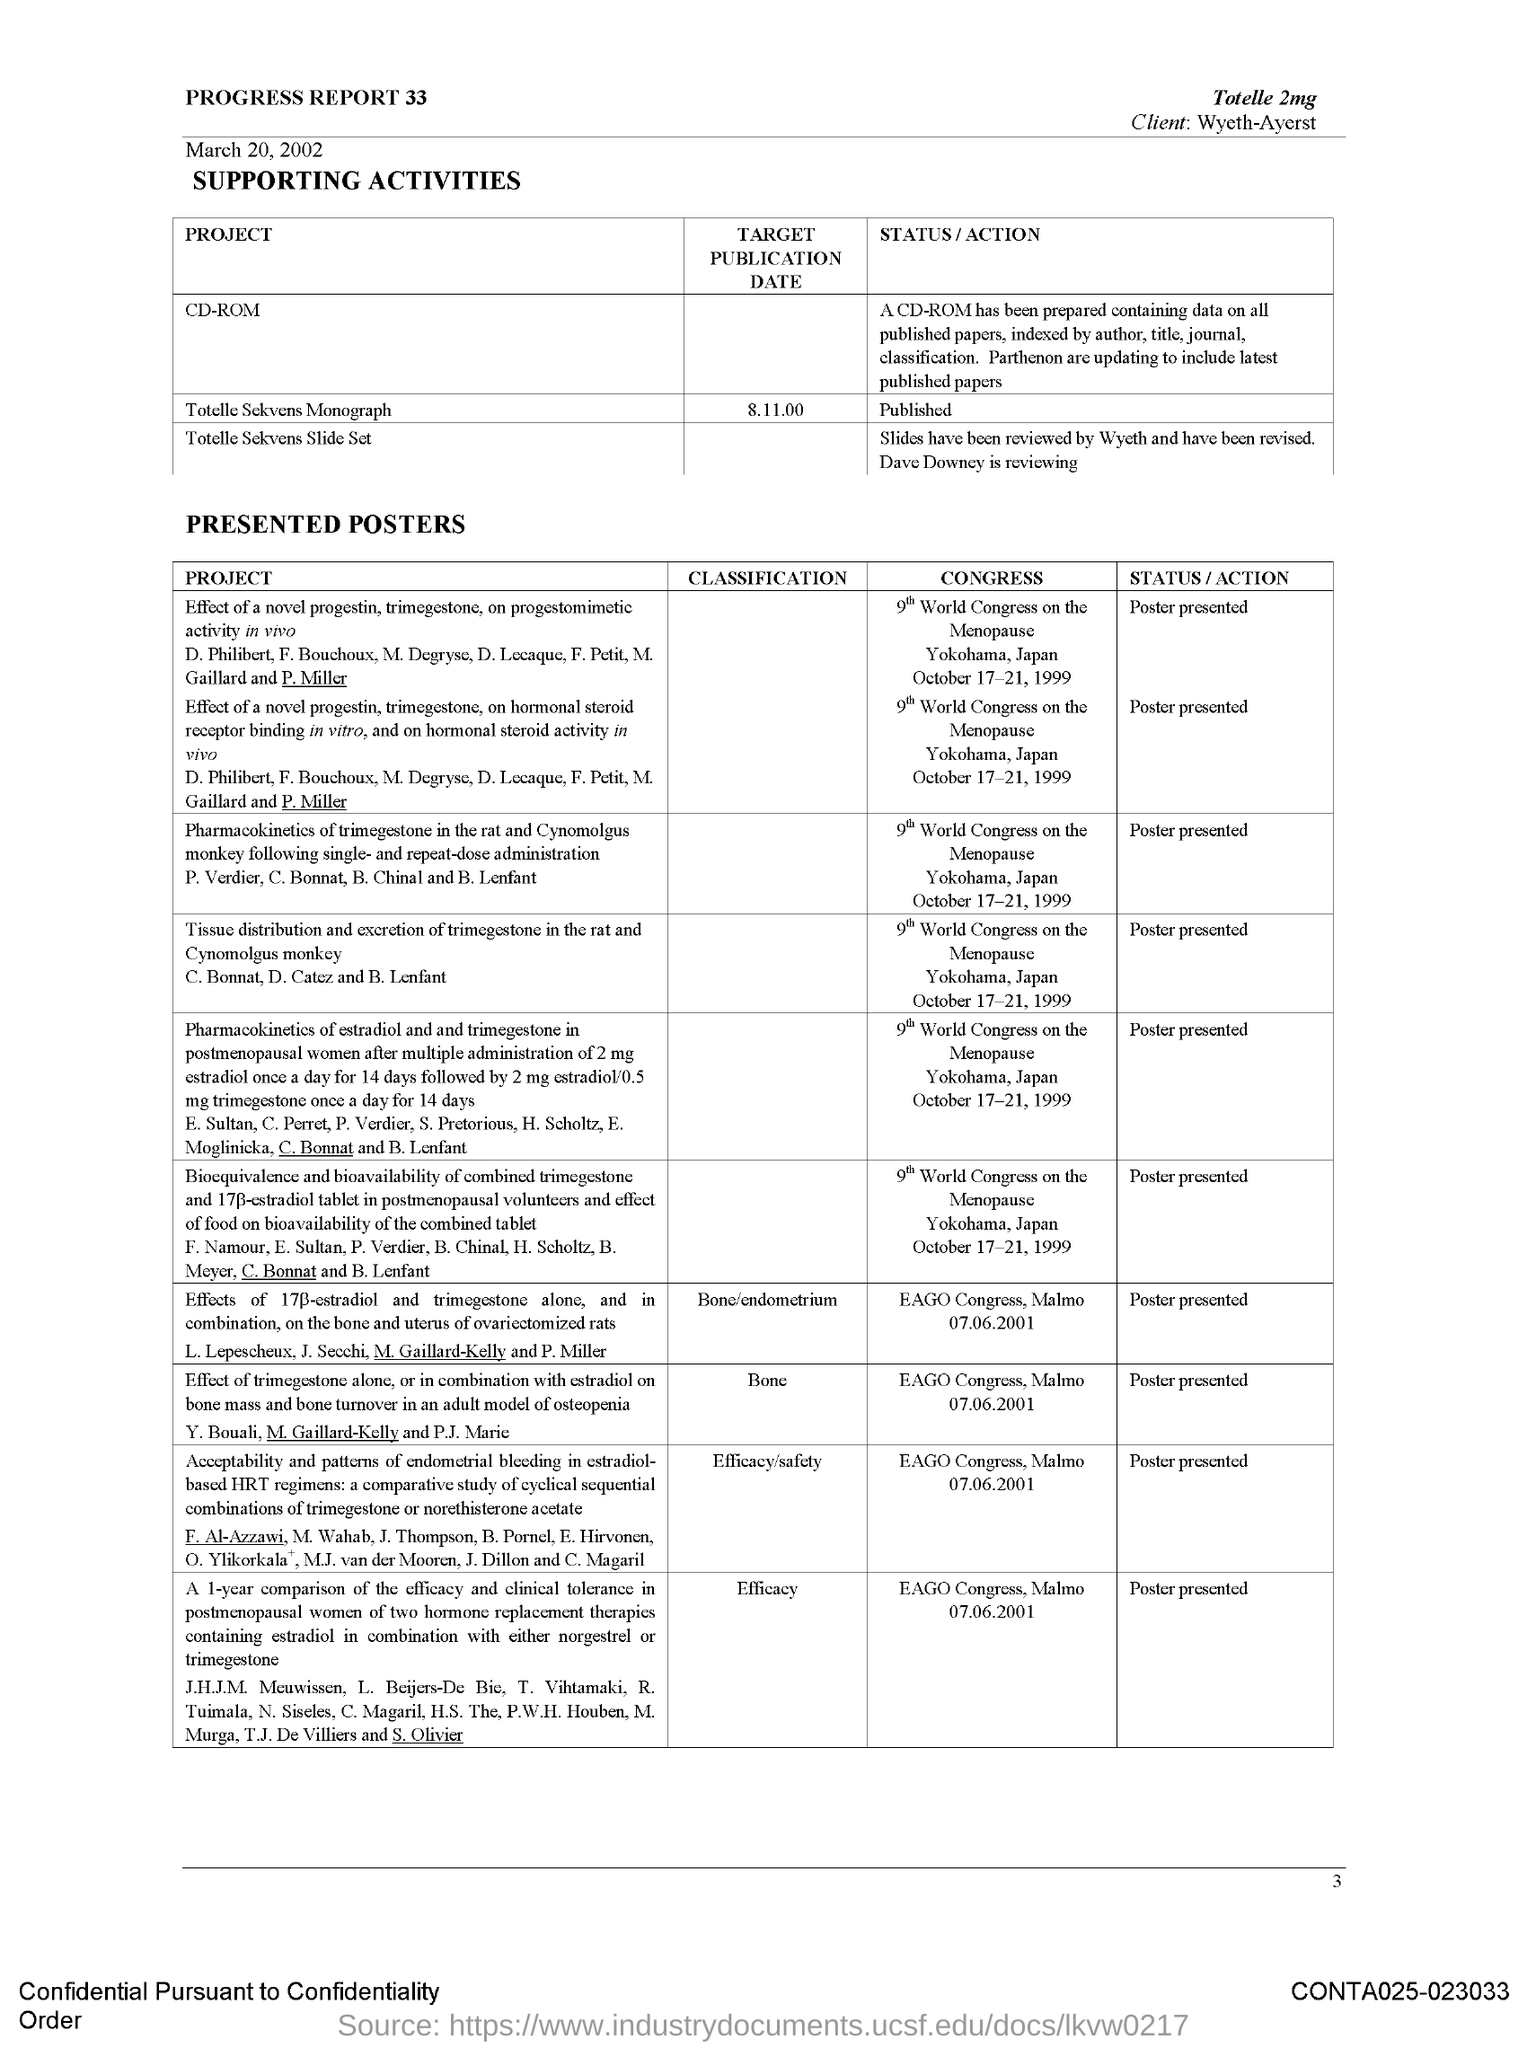Which medicine is mentioned at the top?
Provide a short and direct response. Totelle 2mg. Who is the client?
Ensure brevity in your answer.  Wyeth-Ayerst. What is the status of Totelle Sekvens Monograph?
Provide a short and direct response. Published. 